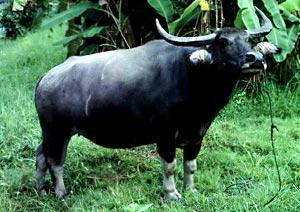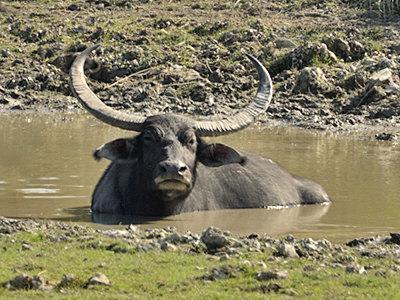The first image is the image on the left, the second image is the image on the right. Considering the images on both sides, is "A single horned animal is in the water." valid? Answer yes or no. Yes. The first image is the image on the left, the second image is the image on the right. Analyze the images presented: Is the assertion "the image on the right contains a water buffalo whose body is submerged in water." valid? Answer yes or no. Yes. 